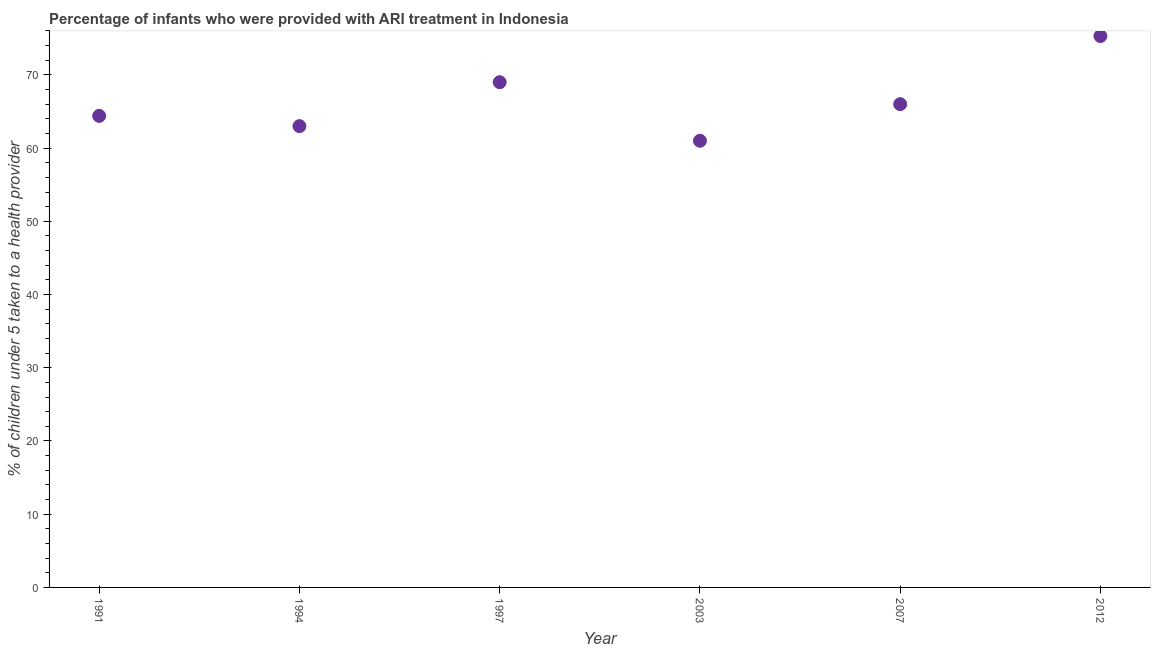Across all years, what is the maximum percentage of children who were provided with ari treatment?
Provide a short and direct response. 75.3. Across all years, what is the minimum percentage of children who were provided with ari treatment?
Offer a very short reply. 61. In which year was the percentage of children who were provided with ari treatment maximum?
Provide a succinct answer. 2012. What is the sum of the percentage of children who were provided with ari treatment?
Ensure brevity in your answer.  398.7. What is the difference between the percentage of children who were provided with ari treatment in 1997 and 2007?
Provide a succinct answer. 3. What is the average percentage of children who were provided with ari treatment per year?
Ensure brevity in your answer.  66.45. What is the median percentage of children who were provided with ari treatment?
Make the answer very short. 65.2. What is the ratio of the percentage of children who were provided with ari treatment in 1994 to that in 1997?
Provide a short and direct response. 0.91. Is the percentage of children who were provided with ari treatment in 1997 less than that in 2012?
Your answer should be compact. Yes. What is the difference between the highest and the second highest percentage of children who were provided with ari treatment?
Keep it short and to the point. 6.3. What is the difference between the highest and the lowest percentage of children who were provided with ari treatment?
Make the answer very short. 14.3. Does the percentage of children who were provided with ari treatment monotonically increase over the years?
Offer a terse response. No. How many dotlines are there?
Your response must be concise. 1. How many years are there in the graph?
Keep it short and to the point. 6. Are the values on the major ticks of Y-axis written in scientific E-notation?
Keep it short and to the point. No. Does the graph contain any zero values?
Offer a terse response. No. What is the title of the graph?
Provide a short and direct response. Percentage of infants who were provided with ARI treatment in Indonesia. What is the label or title of the X-axis?
Make the answer very short. Year. What is the label or title of the Y-axis?
Your answer should be compact. % of children under 5 taken to a health provider. What is the % of children under 5 taken to a health provider in 1991?
Provide a short and direct response. 64.4. What is the % of children under 5 taken to a health provider in 2003?
Offer a very short reply. 61. What is the % of children under 5 taken to a health provider in 2007?
Offer a terse response. 66. What is the % of children under 5 taken to a health provider in 2012?
Offer a very short reply. 75.3. What is the difference between the % of children under 5 taken to a health provider in 1991 and 1994?
Ensure brevity in your answer.  1.4. What is the difference between the % of children under 5 taken to a health provider in 1991 and 1997?
Offer a terse response. -4.6. What is the difference between the % of children under 5 taken to a health provider in 1991 and 2003?
Keep it short and to the point. 3.4. What is the difference between the % of children under 5 taken to a health provider in 1991 and 2007?
Provide a succinct answer. -1.6. What is the difference between the % of children under 5 taken to a health provider in 1994 and 1997?
Give a very brief answer. -6. What is the difference between the % of children under 5 taken to a health provider in 1994 and 2003?
Ensure brevity in your answer.  2. What is the difference between the % of children under 5 taken to a health provider in 1994 and 2012?
Offer a terse response. -12.3. What is the difference between the % of children under 5 taken to a health provider in 1997 and 2003?
Your response must be concise. 8. What is the difference between the % of children under 5 taken to a health provider in 1997 and 2012?
Your answer should be very brief. -6.3. What is the difference between the % of children under 5 taken to a health provider in 2003 and 2007?
Provide a succinct answer. -5. What is the difference between the % of children under 5 taken to a health provider in 2003 and 2012?
Your answer should be compact. -14.3. What is the ratio of the % of children under 5 taken to a health provider in 1991 to that in 1997?
Offer a terse response. 0.93. What is the ratio of the % of children under 5 taken to a health provider in 1991 to that in 2003?
Make the answer very short. 1.06. What is the ratio of the % of children under 5 taken to a health provider in 1991 to that in 2012?
Your answer should be compact. 0.85. What is the ratio of the % of children under 5 taken to a health provider in 1994 to that in 2003?
Provide a succinct answer. 1.03. What is the ratio of the % of children under 5 taken to a health provider in 1994 to that in 2007?
Make the answer very short. 0.95. What is the ratio of the % of children under 5 taken to a health provider in 1994 to that in 2012?
Give a very brief answer. 0.84. What is the ratio of the % of children under 5 taken to a health provider in 1997 to that in 2003?
Give a very brief answer. 1.13. What is the ratio of the % of children under 5 taken to a health provider in 1997 to that in 2007?
Your answer should be compact. 1.04. What is the ratio of the % of children under 5 taken to a health provider in 1997 to that in 2012?
Offer a very short reply. 0.92. What is the ratio of the % of children under 5 taken to a health provider in 2003 to that in 2007?
Keep it short and to the point. 0.92. What is the ratio of the % of children under 5 taken to a health provider in 2003 to that in 2012?
Keep it short and to the point. 0.81. What is the ratio of the % of children under 5 taken to a health provider in 2007 to that in 2012?
Your answer should be compact. 0.88. 